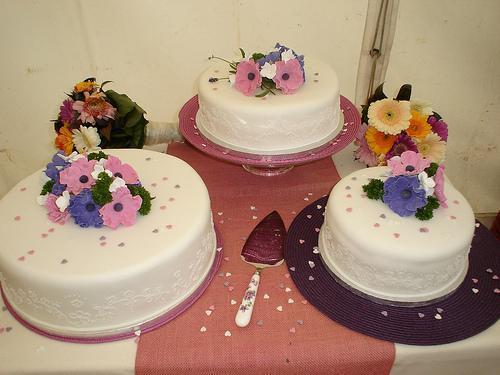How many cakes?
Give a very brief answer. 3. How many cakes are on the table?
Give a very brief answer. 3. 